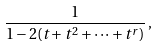<formula> <loc_0><loc_0><loc_500><loc_500>\frac { 1 } { 1 - 2 ( t + t ^ { 2 } + \dots + t ^ { r } ) } \, ,</formula> 